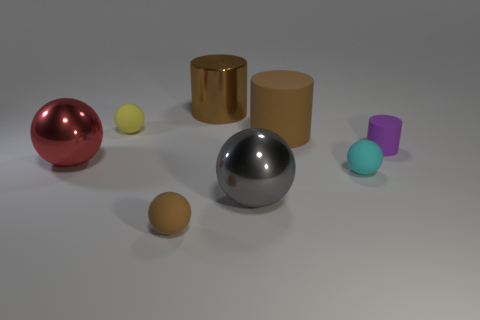Subtract all cyan balls. How many balls are left? 4 Subtract all large red metallic spheres. How many spheres are left? 4 Subtract 2 spheres. How many spheres are left? 3 Subtract all brown cylinders. Subtract all cyan blocks. How many cylinders are left? 1 Add 1 metallic spheres. How many objects exist? 9 Subtract all cylinders. How many objects are left? 5 Subtract all tiny green cubes. Subtract all small cyan objects. How many objects are left? 7 Add 1 cyan balls. How many cyan balls are left? 2 Add 1 large metal objects. How many large metal objects exist? 4 Subtract 0 purple blocks. How many objects are left? 8 